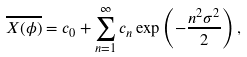Convert formula to latex. <formula><loc_0><loc_0><loc_500><loc_500>\overline { X ( \phi ) } = c _ { 0 } + \sum _ { n = 1 } ^ { \infty } c _ { n } \exp \left ( - \frac { n ^ { 2 } \sigma ^ { 2 } } { 2 } \right ) ,</formula> 